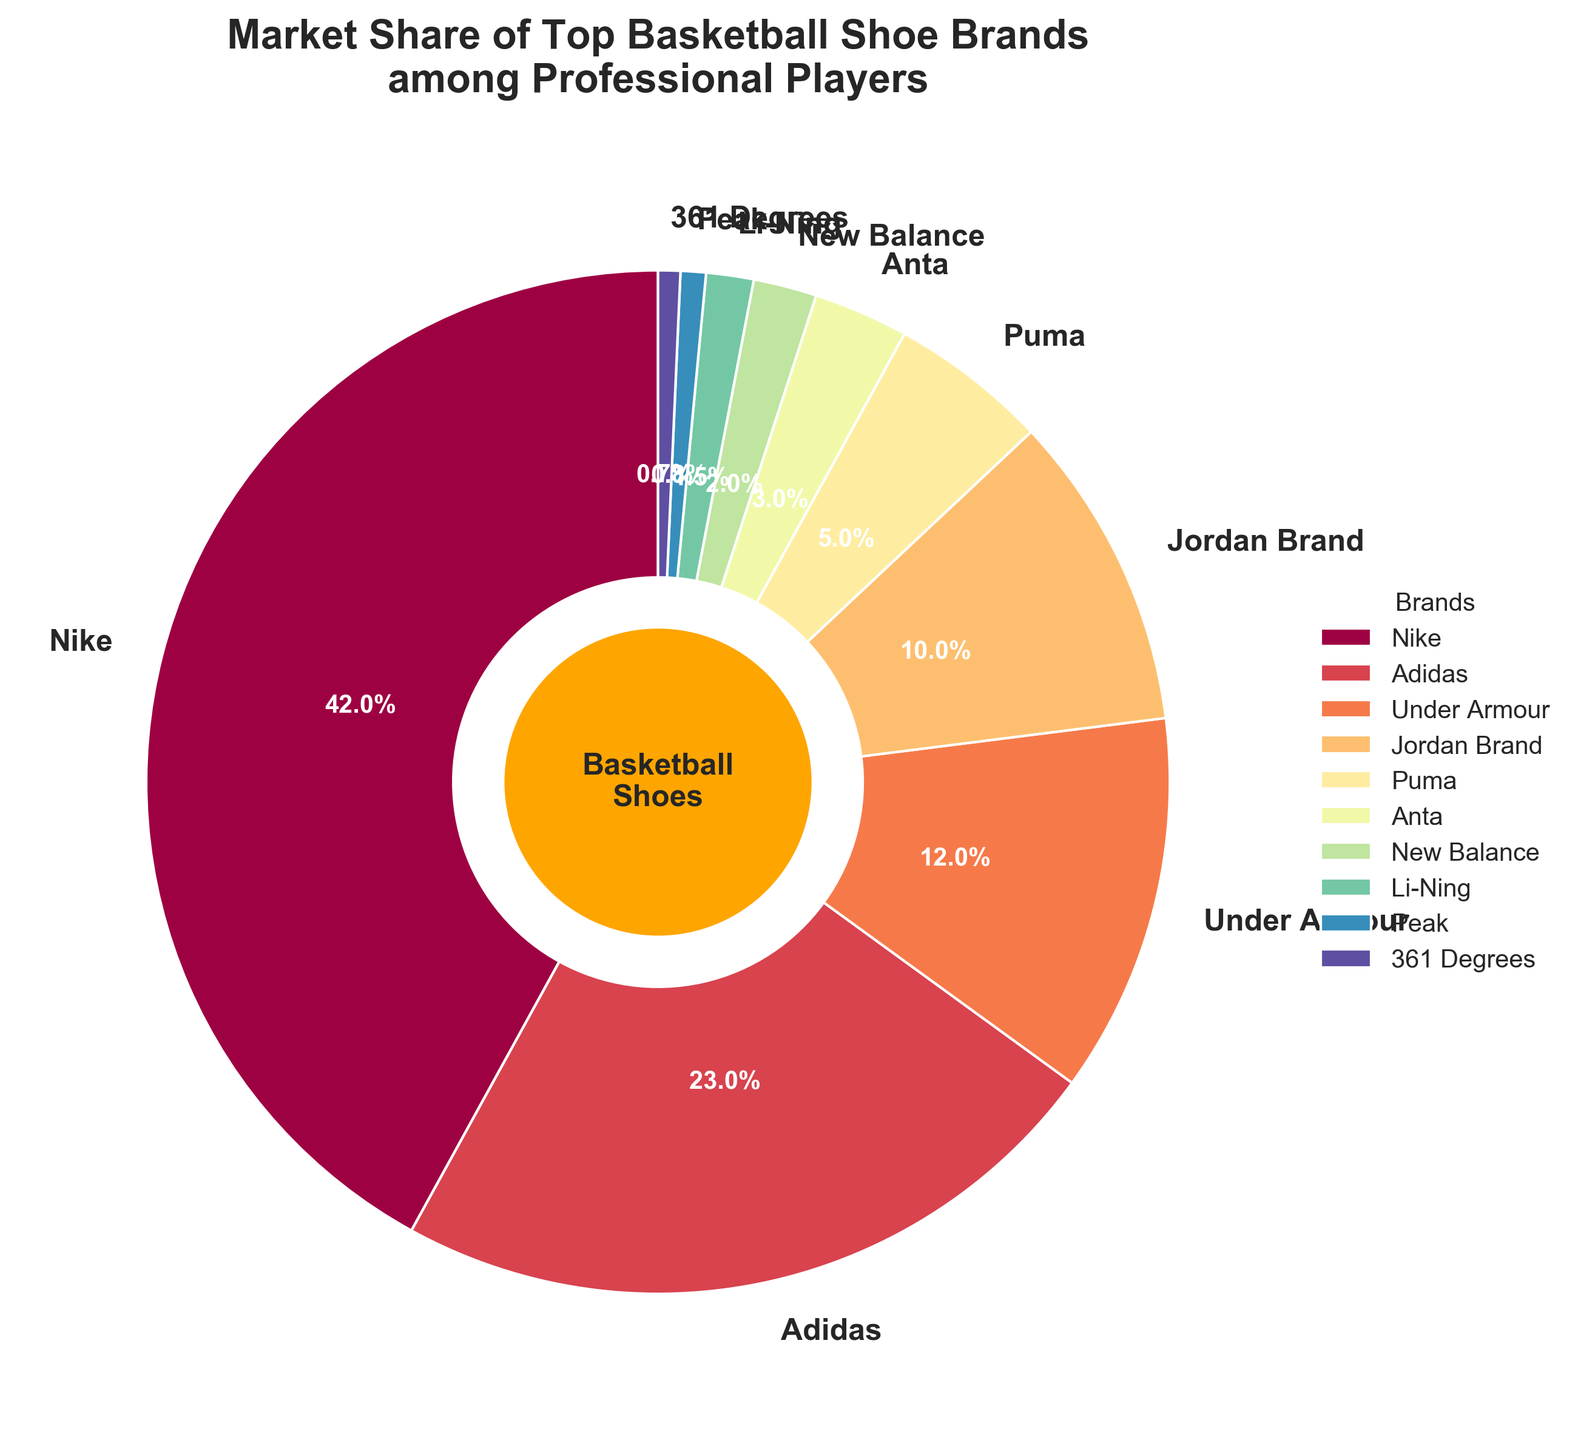What is the market share of Nike compared to the total market share of Adidas and Under Armour? The market share of Nike is 42%. The total market share of Adidas and Under Armour is 23% + 12% = 35%. Hence, Nike's market share is higher.
Answer: Nike's share is higher Which brand has the smallest market share among professional players? The smallest market share is held by 361 Degrees at 0.7%, as visually indicated by its smallest wedge in the pie chart.
Answer: 361 Degrees Which three brands have the largest market shares, and what percentage of the total market do they capture together? The three brands with the largest market shares are Nike (42%), Adidas (23%), and Under Armour (12%). Their combined market share is 42% + 23% + 12% = 77%.
Answer: Nike, Adidas, Under Armour; 77% If we combine the market shares of Jordan Brand, Puma, Anta, New Balance, Li-Ning, Peak, and 361 Degrees, would it exceed Nike's market share alone? The combined market share of Jordan Brand (10%), Puma (5%), Anta (3%), New Balance (2%), Li-Ning (1.5%), Peak (0.8%), and 361 Degrees (0.7%) is 10% + 5% + 3% + 2% + 1.5% + 0.8% + 0.7% = 23.0%. Nike's market share is 42%, which is greater than this combined total.
Answer: No What brand, other than Nike, has a market share that exceeds 20%? By observing the pie chart, Adidas at 23% is the only brand other than Nike with a market share exceeding 20%.
Answer: Adidas What are the cumulative market shares of shoes brands that have a market share less than 10%? The brands with market shares less than 10% are Puma (5%), Anta (3%), New Balance (2%), Li-Ning (1.5%), Peak (0.8%), and 361 Degrees (0.7%). Their cumulative market share is 5% + 3% + 2% + 1.5% + 0.8% + 0.7% = 13%.
Answer: 13% Which brand has a market share closest to the median market share of all listed brands? To find the median market share, the shares are sorted: 0.7%, 0.8%, 1.5%, 2%, 3%, 5%, 10%, 12%, 23%, 42%. The median of these 10 values is the average of the 5th and 6th values, (3% + 5%) / 2 = 4%. The brand closest to this is Puma at 5%.
Answer: Puma What is the difference in market share between Jordan Brand and Adidas? Jordan Brand has a market share of 10%, while Adidas has 23%. The difference is 23% - 10% = 13%.
Answer: 13% 